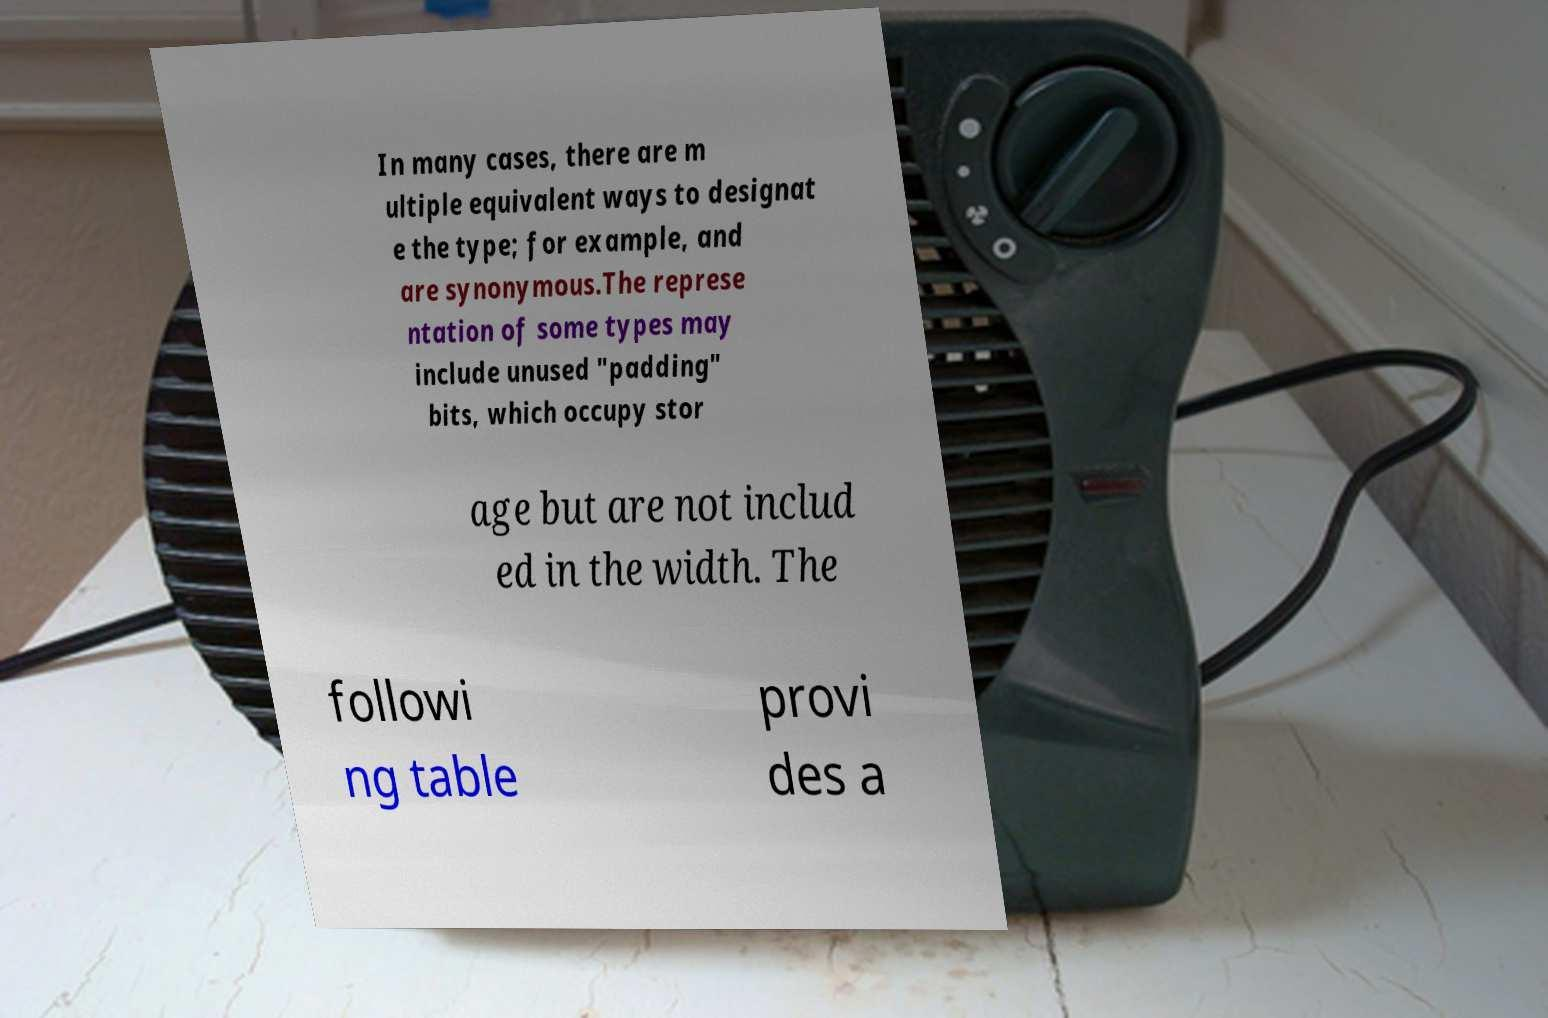Could you extract and type out the text from this image? In many cases, there are m ultiple equivalent ways to designat e the type; for example, and are synonymous.The represe ntation of some types may include unused "padding" bits, which occupy stor age but are not includ ed in the width. The followi ng table provi des a 